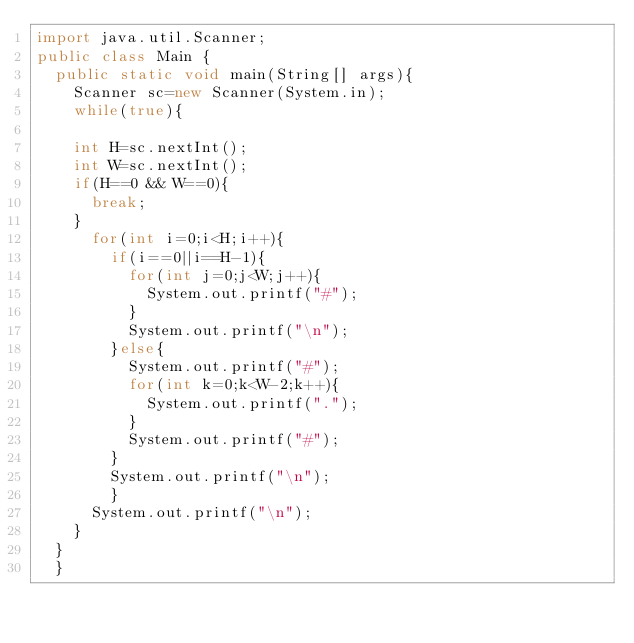<code> <loc_0><loc_0><loc_500><loc_500><_Java_>import java.util.Scanner;
public class Main {
	public static void main(String[] args){
		Scanner sc=new Scanner(System.in);
		while(true){
		
		int H=sc.nextInt();
		int W=sc.nextInt();
		if(H==0 && W==0){
			break;
		}
			for(int i=0;i<H;i++){
				if(i==0||i==H-1){
					for(int j=0;j<W;j++){
						System.out.printf("#");
					}
					System.out.printf("\n");
				}else{
					System.out.printf("#");
					for(int k=0;k<W-2;k++){
						System.out.printf(".");
					}
					System.out.printf("#");
				}
				System.out.printf("\n");
				}
			System.out.printf("\n");
		}
	}
	}</code> 